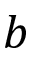Convert formula to latex. <formula><loc_0><loc_0><loc_500><loc_500>b</formula> 